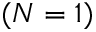<formula> <loc_0><loc_0><loc_500><loc_500>( N = 1 )</formula> 